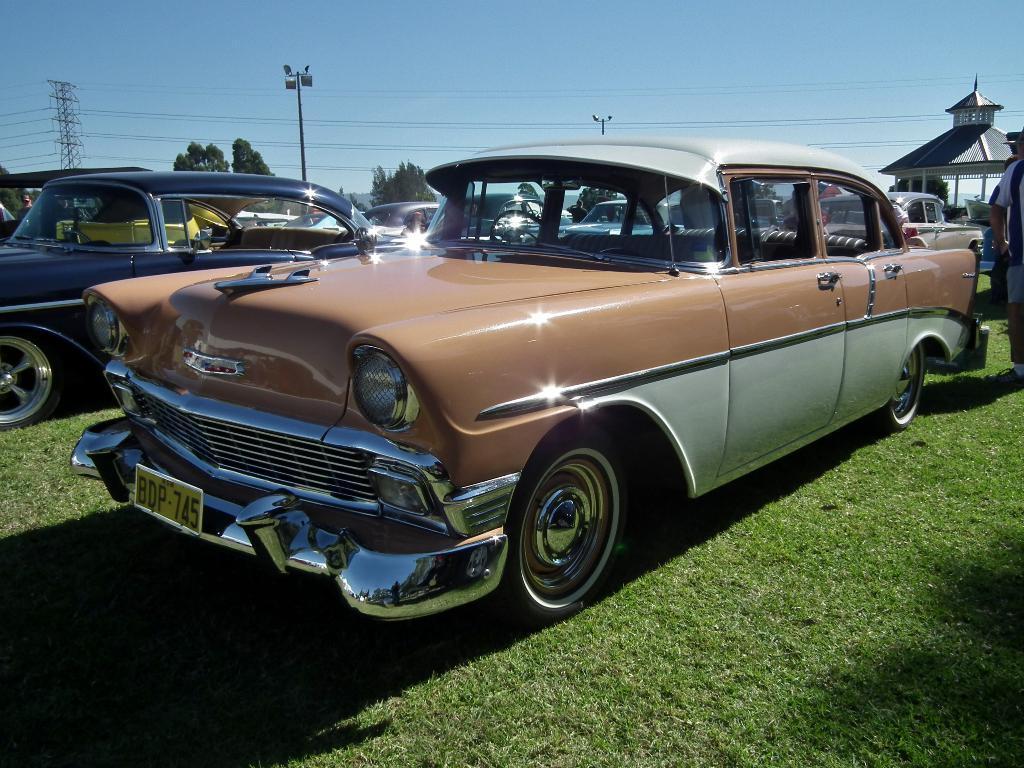Could you give a brief overview of what you see in this image? In this image I can see few vehicles, tower, wires, light poles, house, few people and few trees. The sky is in blue color. 